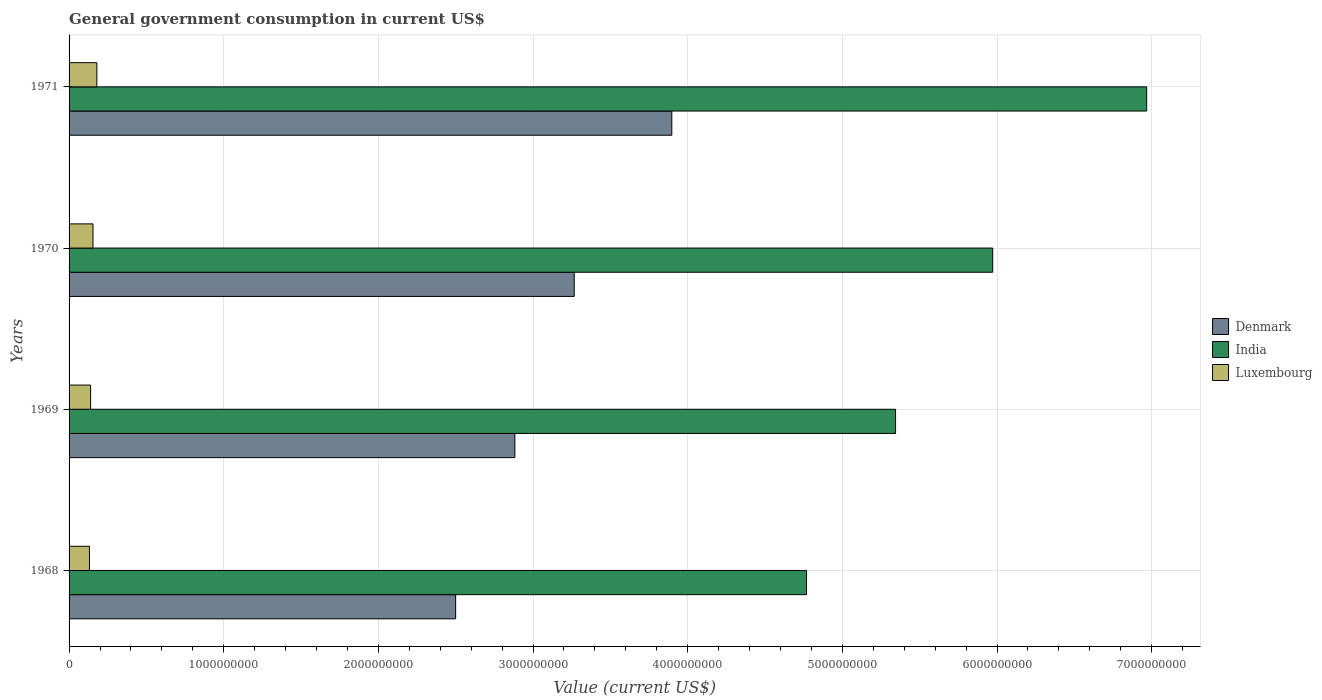How many different coloured bars are there?
Your answer should be compact. 3. How many groups of bars are there?
Ensure brevity in your answer.  4. Are the number of bars per tick equal to the number of legend labels?
Ensure brevity in your answer.  Yes. How many bars are there on the 4th tick from the top?
Provide a short and direct response. 3. What is the label of the 1st group of bars from the top?
Provide a succinct answer. 1971. What is the government conusmption in Denmark in 1970?
Offer a terse response. 3.27e+09. Across all years, what is the maximum government conusmption in Luxembourg?
Your response must be concise. 1.80e+08. Across all years, what is the minimum government conusmption in Luxembourg?
Your response must be concise. 1.32e+08. In which year was the government conusmption in Denmark minimum?
Your answer should be very brief. 1968. What is the total government conusmption in India in the graph?
Offer a very short reply. 2.31e+1. What is the difference between the government conusmption in Luxembourg in 1969 and that in 1971?
Your answer should be very brief. -4.05e+07. What is the difference between the government conusmption in Denmark in 1971 and the government conusmption in India in 1969?
Your answer should be compact. -1.45e+09. What is the average government conusmption in Denmark per year?
Keep it short and to the point. 3.14e+09. In the year 1968, what is the difference between the government conusmption in Denmark and government conusmption in India?
Your response must be concise. -2.27e+09. In how many years, is the government conusmption in India greater than 5000000000 US$?
Provide a short and direct response. 3. What is the ratio of the government conusmption in Luxembourg in 1970 to that in 1971?
Provide a succinct answer. 0.86. Is the government conusmption in Luxembourg in 1968 less than that in 1971?
Provide a succinct answer. Yes. Is the difference between the government conusmption in Denmark in 1969 and 1970 greater than the difference between the government conusmption in India in 1969 and 1970?
Offer a very short reply. Yes. What is the difference between the highest and the second highest government conusmption in Denmark?
Ensure brevity in your answer.  6.31e+08. What is the difference between the highest and the lowest government conusmption in Denmark?
Provide a short and direct response. 1.40e+09. What does the 3rd bar from the top in 1969 represents?
Provide a short and direct response. Denmark. Is it the case that in every year, the sum of the government conusmption in Denmark and government conusmption in Luxembourg is greater than the government conusmption in India?
Provide a succinct answer. No. How many bars are there?
Offer a very short reply. 12. How many years are there in the graph?
Provide a short and direct response. 4. Are the values on the major ticks of X-axis written in scientific E-notation?
Give a very brief answer. No. Does the graph contain any zero values?
Your response must be concise. No. How are the legend labels stacked?
Provide a short and direct response. Vertical. What is the title of the graph?
Provide a succinct answer. General government consumption in current US$. What is the label or title of the X-axis?
Provide a short and direct response. Value (current US$). What is the label or title of the Y-axis?
Your response must be concise. Years. What is the Value (current US$) of Denmark in 1968?
Keep it short and to the point. 2.50e+09. What is the Value (current US$) of India in 1968?
Make the answer very short. 4.77e+09. What is the Value (current US$) in Luxembourg in 1968?
Provide a succinct answer. 1.32e+08. What is the Value (current US$) in Denmark in 1969?
Provide a succinct answer. 2.88e+09. What is the Value (current US$) of India in 1969?
Offer a very short reply. 5.34e+09. What is the Value (current US$) in Luxembourg in 1969?
Give a very brief answer. 1.39e+08. What is the Value (current US$) of Denmark in 1970?
Provide a short and direct response. 3.27e+09. What is the Value (current US$) in India in 1970?
Your answer should be compact. 5.97e+09. What is the Value (current US$) in Luxembourg in 1970?
Provide a succinct answer. 1.55e+08. What is the Value (current US$) in Denmark in 1971?
Provide a succinct answer. 3.90e+09. What is the Value (current US$) in India in 1971?
Provide a short and direct response. 6.97e+09. What is the Value (current US$) in Luxembourg in 1971?
Your answer should be compact. 1.80e+08. Across all years, what is the maximum Value (current US$) in Denmark?
Offer a terse response. 3.90e+09. Across all years, what is the maximum Value (current US$) of India?
Your answer should be compact. 6.97e+09. Across all years, what is the maximum Value (current US$) of Luxembourg?
Keep it short and to the point. 1.80e+08. Across all years, what is the minimum Value (current US$) of Denmark?
Give a very brief answer. 2.50e+09. Across all years, what is the minimum Value (current US$) of India?
Provide a succinct answer. 4.77e+09. Across all years, what is the minimum Value (current US$) in Luxembourg?
Keep it short and to the point. 1.32e+08. What is the total Value (current US$) in Denmark in the graph?
Your answer should be compact. 1.25e+1. What is the total Value (current US$) of India in the graph?
Keep it short and to the point. 2.31e+1. What is the total Value (current US$) of Luxembourg in the graph?
Give a very brief answer. 6.05e+08. What is the difference between the Value (current US$) in Denmark in 1968 and that in 1969?
Make the answer very short. -3.83e+08. What is the difference between the Value (current US$) of India in 1968 and that in 1969?
Offer a very short reply. -5.76e+08. What is the difference between the Value (current US$) in Luxembourg in 1968 and that in 1969?
Offer a terse response. -7.47e+06. What is the difference between the Value (current US$) of Denmark in 1968 and that in 1970?
Ensure brevity in your answer.  -7.67e+08. What is the difference between the Value (current US$) of India in 1968 and that in 1970?
Your answer should be compact. -1.20e+09. What is the difference between the Value (current US$) in Luxembourg in 1968 and that in 1970?
Provide a succinct answer. -2.29e+07. What is the difference between the Value (current US$) in Denmark in 1968 and that in 1971?
Provide a succinct answer. -1.40e+09. What is the difference between the Value (current US$) of India in 1968 and that in 1971?
Your answer should be compact. -2.20e+09. What is the difference between the Value (current US$) of Luxembourg in 1968 and that in 1971?
Offer a very short reply. -4.80e+07. What is the difference between the Value (current US$) in Denmark in 1969 and that in 1970?
Make the answer very short. -3.84e+08. What is the difference between the Value (current US$) in India in 1969 and that in 1970?
Provide a succinct answer. -6.28e+08. What is the difference between the Value (current US$) of Luxembourg in 1969 and that in 1970?
Offer a terse response. -1.55e+07. What is the difference between the Value (current US$) of Denmark in 1969 and that in 1971?
Give a very brief answer. -1.01e+09. What is the difference between the Value (current US$) in India in 1969 and that in 1971?
Keep it short and to the point. -1.62e+09. What is the difference between the Value (current US$) of Luxembourg in 1969 and that in 1971?
Your answer should be compact. -4.05e+07. What is the difference between the Value (current US$) in Denmark in 1970 and that in 1971?
Offer a very short reply. -6.31e+08. What is the difference between the Value (current US$) in India in 1970 and that in 1971?
Your answer should be compact. -9.96e+08. What is the difference between the Value (current US$) in Luxembourg in 1970 and that in 1971?
Offer a terse response. -2.50e+07. What is the difference between the Value (current US$) in Denmark in 1968 and the Value (current US$) in India in 1969?
Provide a short and direct response. -2.84e+09. What is the difference between the Value (current US$) in Denmark in 1968 and the Value (current US$) in Luxembourg in 1969?
Ensure brevity in your answer.  2.36e+09. What is the difference between the Value (current US$) of India in 1968 and the Value (current US$) of Luxembourg in 1969?
Offer a terse response. 4.63e+09. What is the difference between the Value (current US$) in Denmark in 1968 and the Value (current US$) in India in 1970?
Your answer should be very brief. -3.47e+09. What is the difference between the Value (current US$) in Denmark in 1968 and the Value (current US$) in Luxembourg in 1970?
Your answer should be very brief. 2.34e+09. What is the difference between the Value (current US$) of India in 1968 and the Value (current US$) of Luxembourg in 1970?
Ensure brevity in your answer.  4.61e+09. What is the difference between the Value (current US$) of Denmark in 1968 and the Value (current US$) of India in 1971?
Make the answer very short. -4.47e+09. What is the difference between the Value (current US$) of Denmark in 1968 and the Value (current US$) of Luxembourg in 1971?
Provide a short and direct response. 2.32e+09. What is the difference between the Value (current US$) of India in 1968 and the Value (current US$) of Luxembourg in 1971?
Your response must be concise. 4.59e+09. What is the difference between the Value (current US$) of Denmark in 1969 and the Value (current US$) of India in 1970?
Provide a succinct answer. -3.09e+09. What is the difference between the Value (current US$) in Denmark in 1969 and the Value (current US$) in Luxembourg in 1970?
Provide a succinct answer. 2.73e+09. What is the difference between the Value (current US$) in India in 1969 and the Value (current US$) in Luxembourg in 1970?
Your response must be concise. 5.19e+09. What is the difference between the Value (current US$) in Denmark in 1969 and the Value (current US$) in India in 1971?
Your answer should be very brief. -4.09e+09. What is the difference between the Value (current US$) in Denmark in 1969 and the Value (current US$) in Luxembourg in 1971?
Your answer should be very brief. 2.70e+09. What is the difference between the Value (current US$) of India in 1969 and the Value (current US$) of Luxembourg in 1971?
Give a very brief answer. 5.16e+09. What is the difference between the Value (current US$) of Denmark in 1970 and the Value (current US$) of India in 1971?
Your answer should be compact. -3.70e+09. What is the difference between the Value (current US$) in Denmark in 1970 and the Value (current US$) in Luxembourg in 1971?
Ensure brevity in your answer.  3.09e+09. What is the difference between the Value (current US$) in India in 1970 and the Value (current US$) in Luxembourg in 1971?
Provide a succinct answer. 5.79e+09. What is the average Value (current US$) in Denmark per year?
Provide a short and direct response. 3.14e+09. What is the average Value (current US$) of India per year?
Provide a succinct answer. 5.76e+09. What is the average Value (current US$) of Luxembourg per year?
Your answer should be very brief. 1.51e+08. In the year 1968, what is the difference between the Value (current US$) in Denmark and Value (current US$) in India?
Ensure brevity in your answer.  -2.27e+09. In the year 1968, what is the difference between the Value (current US$) of Denmark and Value (current US$) of Luxembourg?
Your response must be concise. 2.37e+09. In the year 1968, what is the difference between the Value (current US$) in India and Value (current US$) in Luxembourg?
Your response must be concise. 4.64e+09. In the year 1969, what is the difference between the Value (current US$) of Denmark and Value (current US$) of India?
Provide a succinct answer. -2.46e+09. In the year 1969, what is the difference between the Value (current US$) in Denmark and Value (current US$) in Luxembourg?
Give a very brief answer. 2.74e+09. In the year 1969, what is the difference between the Value (current US$) of India and Value (current US$) of Luxembourg?
Provide a succinct answer. 5.20e+09. In the year 1970, what is the difference between the Value (current US$) of Denmark and Value (current US$) of India?
Your answer should be compact. -2.71e+09. In the year 1970, what is the difference between the Value (current US$) of Denmark and Value (current US$) of Luxembourg?
Your answer should be very brief. 3.11e+09. In the year 1970, what is the difference between the Value (current US$) in India and Value (current US$) in Luxembourg?
Give a very brief answer. 5.82e+09. In the year 1971, what is the difference between the Value (current US$) in Denmark and Value (current US$) in India?
Offer a terse response. -3.07e+09. In the year 1971, what is the difference between the Value (current US$) in Denmark and Value (current US$) in Luxembourg?
Ensure brevity in your answer.  3.72e+09. In the year 1971, what is the difference between the Value (current US$) of India and Value (current US$) of Luxembourg?
Offer a terse response. 6.79e+09. What is the ratio of the Value (current US$) of Denmark in 1968 to that in 1969?
Your answer should be very brief. 0.87. What is the ratio of the Value (current US$) in India in 1968 to that in 1969?
Your answer should be compact. 0.89. What is the ratio of the Value (current US$) in Luxembourg in 1968 to that in 1969?
Your answer should be compact. 0.95. What is the ratio of the Value (current US$) of Denmark in 1968 to that in 1970?
Offer a terse response. 0.77. What is the ratio of the Value (current US$) of India in 1968 to that in 1970?
Ensure brevity in your answer.  0.8. What is the ratio of the Value (current US$) of Luxembourg in 1968 to that in 1970?
Keep it short and to the point. 0.85. What is the ratio of the Value (current US$) in Denmark in 1968 to that in 1971?
Offer a very short reply. 0.64. What is the ratio of the Value (current US$) of India in 1968 to that in 1971?
Give a very brief answer. 0.68. What is the ratio of the Value (current US$) of Luxembourg in 1968 to that in 1971?
Offer a very short reply. 0.73. What is the ratio of the Value (current US$) in Denmark in 1969 to that in 1970?
Provide a succinct answer. 0.88. What is the ratio of the Value (current US$) of India in 1969 to that in 1970?
Provide a short and direct response. 0.89. What is the ratio of the Value (current US$) of Luxembourg in 1969 to that in 1970?
Your answer should be very brief. 0.9. What is the ratio of the Value (current US$) of Denmark in 1969 to that in 1971?
Provide a succinct answer. 0.74. What is the ratio of the Value (current US$) of India in 1969 to that in 1971?
Offer a very short reply. 0.77. What is the ratio of the Value (current US$) of Luxembourg in 1969 to that in 1971?
Make the answer very short. 0.77. What is the ratio of the Value (current US$) in Denmark in 1970 to that in 1971?
Provide a succinct answer. 0.84. What is the ratio of the Value (current US$) in India in 1970 to that in 1971?
Give a very brief answer. 0.86. What is the ratio of the Value (current US$) of Luxembourg in 1970 to that in 1971?
Offer a terse response. 0.86. What is the difference between the highest and the second highest Value (current US$) of Denmark?
Provide a succinct answer. 6.31e+08. What is the difference between the highest and the second highest Value (current US$) in India?
Provide a short and direct response. 9.96e+08. What is the difference between the highest and the second highest Value (current US$) in Luxembourg?
Ensure brevity in your answer.  2.50e+07. What is the difference between the highest and the lowest Value (current US$) in Denmark?
Ensure brevity in your answer.  1.40e+09. What is the difference between the highest and the lowest Value (current US$) of India?
Offer a very short reply. 2.20e+09. What is the difference between the highest and the lowest Value (current US$) in Luxembourg?
Keep it short and to the point. 4.80e+07. 